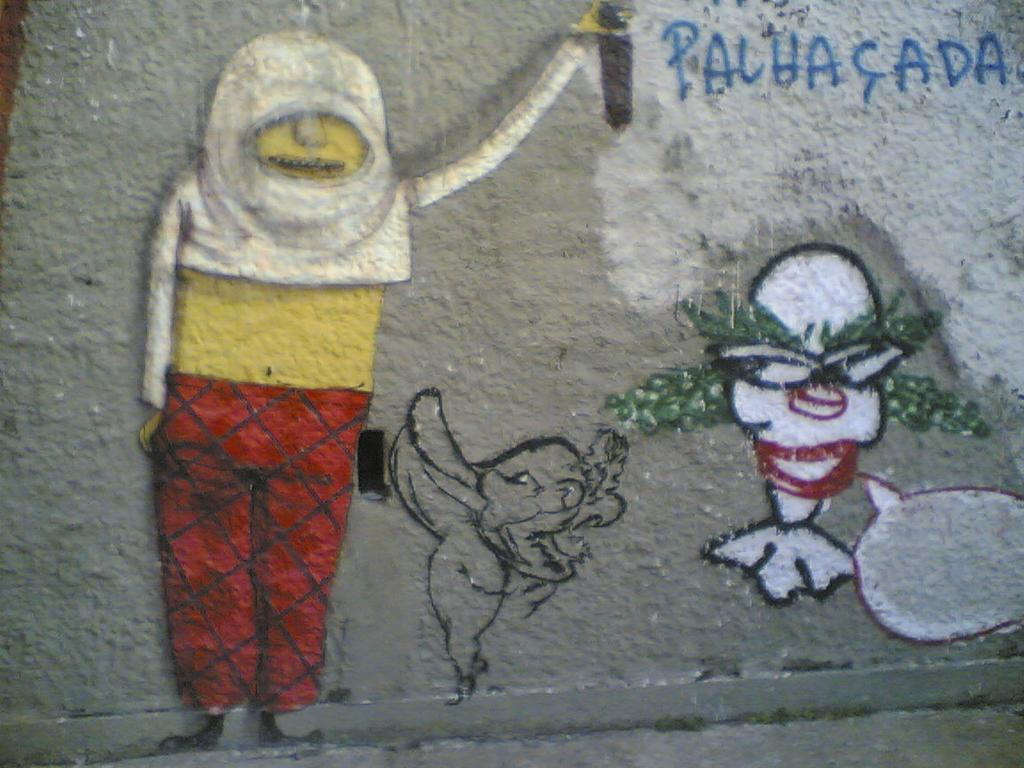What is present on the wall in the image? There are paintings and letters on the wall in the image. Can you describe the paintings on the wall? Unfortunately, the details of the paintings cannot be determined from the image alone. What type of writing is present on the wall? There are letters on the wall, but their content cannot be determined from the image alone. Where is the sofa located in the image? There is no sofa present in the image. What type of liquid can be seen flowing from the paintings on the wall? There is no liquid present in the image; the paintings and letters are stationary on the wall. 